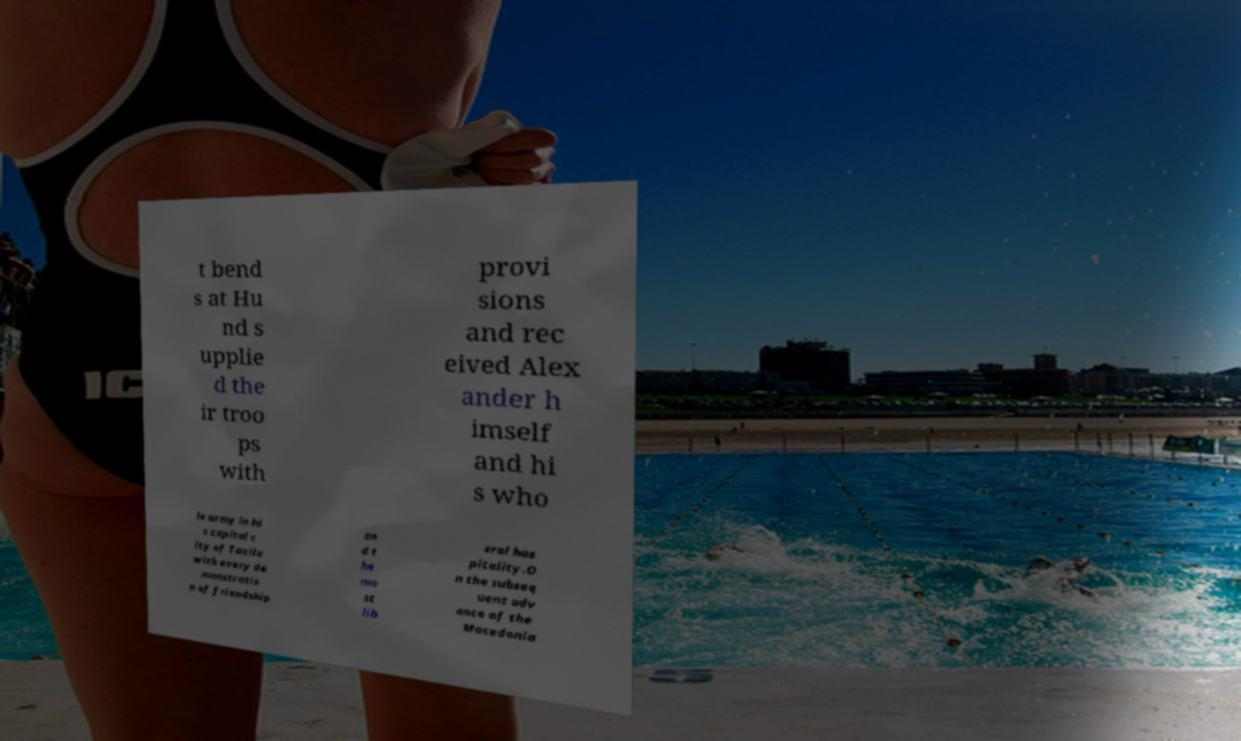Please identify and transcribe the text found in this image. t bend s at Hu nd s upplie d the ir troo ps with provi sions and rec eived Alex ander h imself and hi s who le army in hi s capital c ity of Taxila with every de monstratio n of friendship an d t he mo st lib eral hos pitality.O n the subseq uent adv ance of the Macedonia 